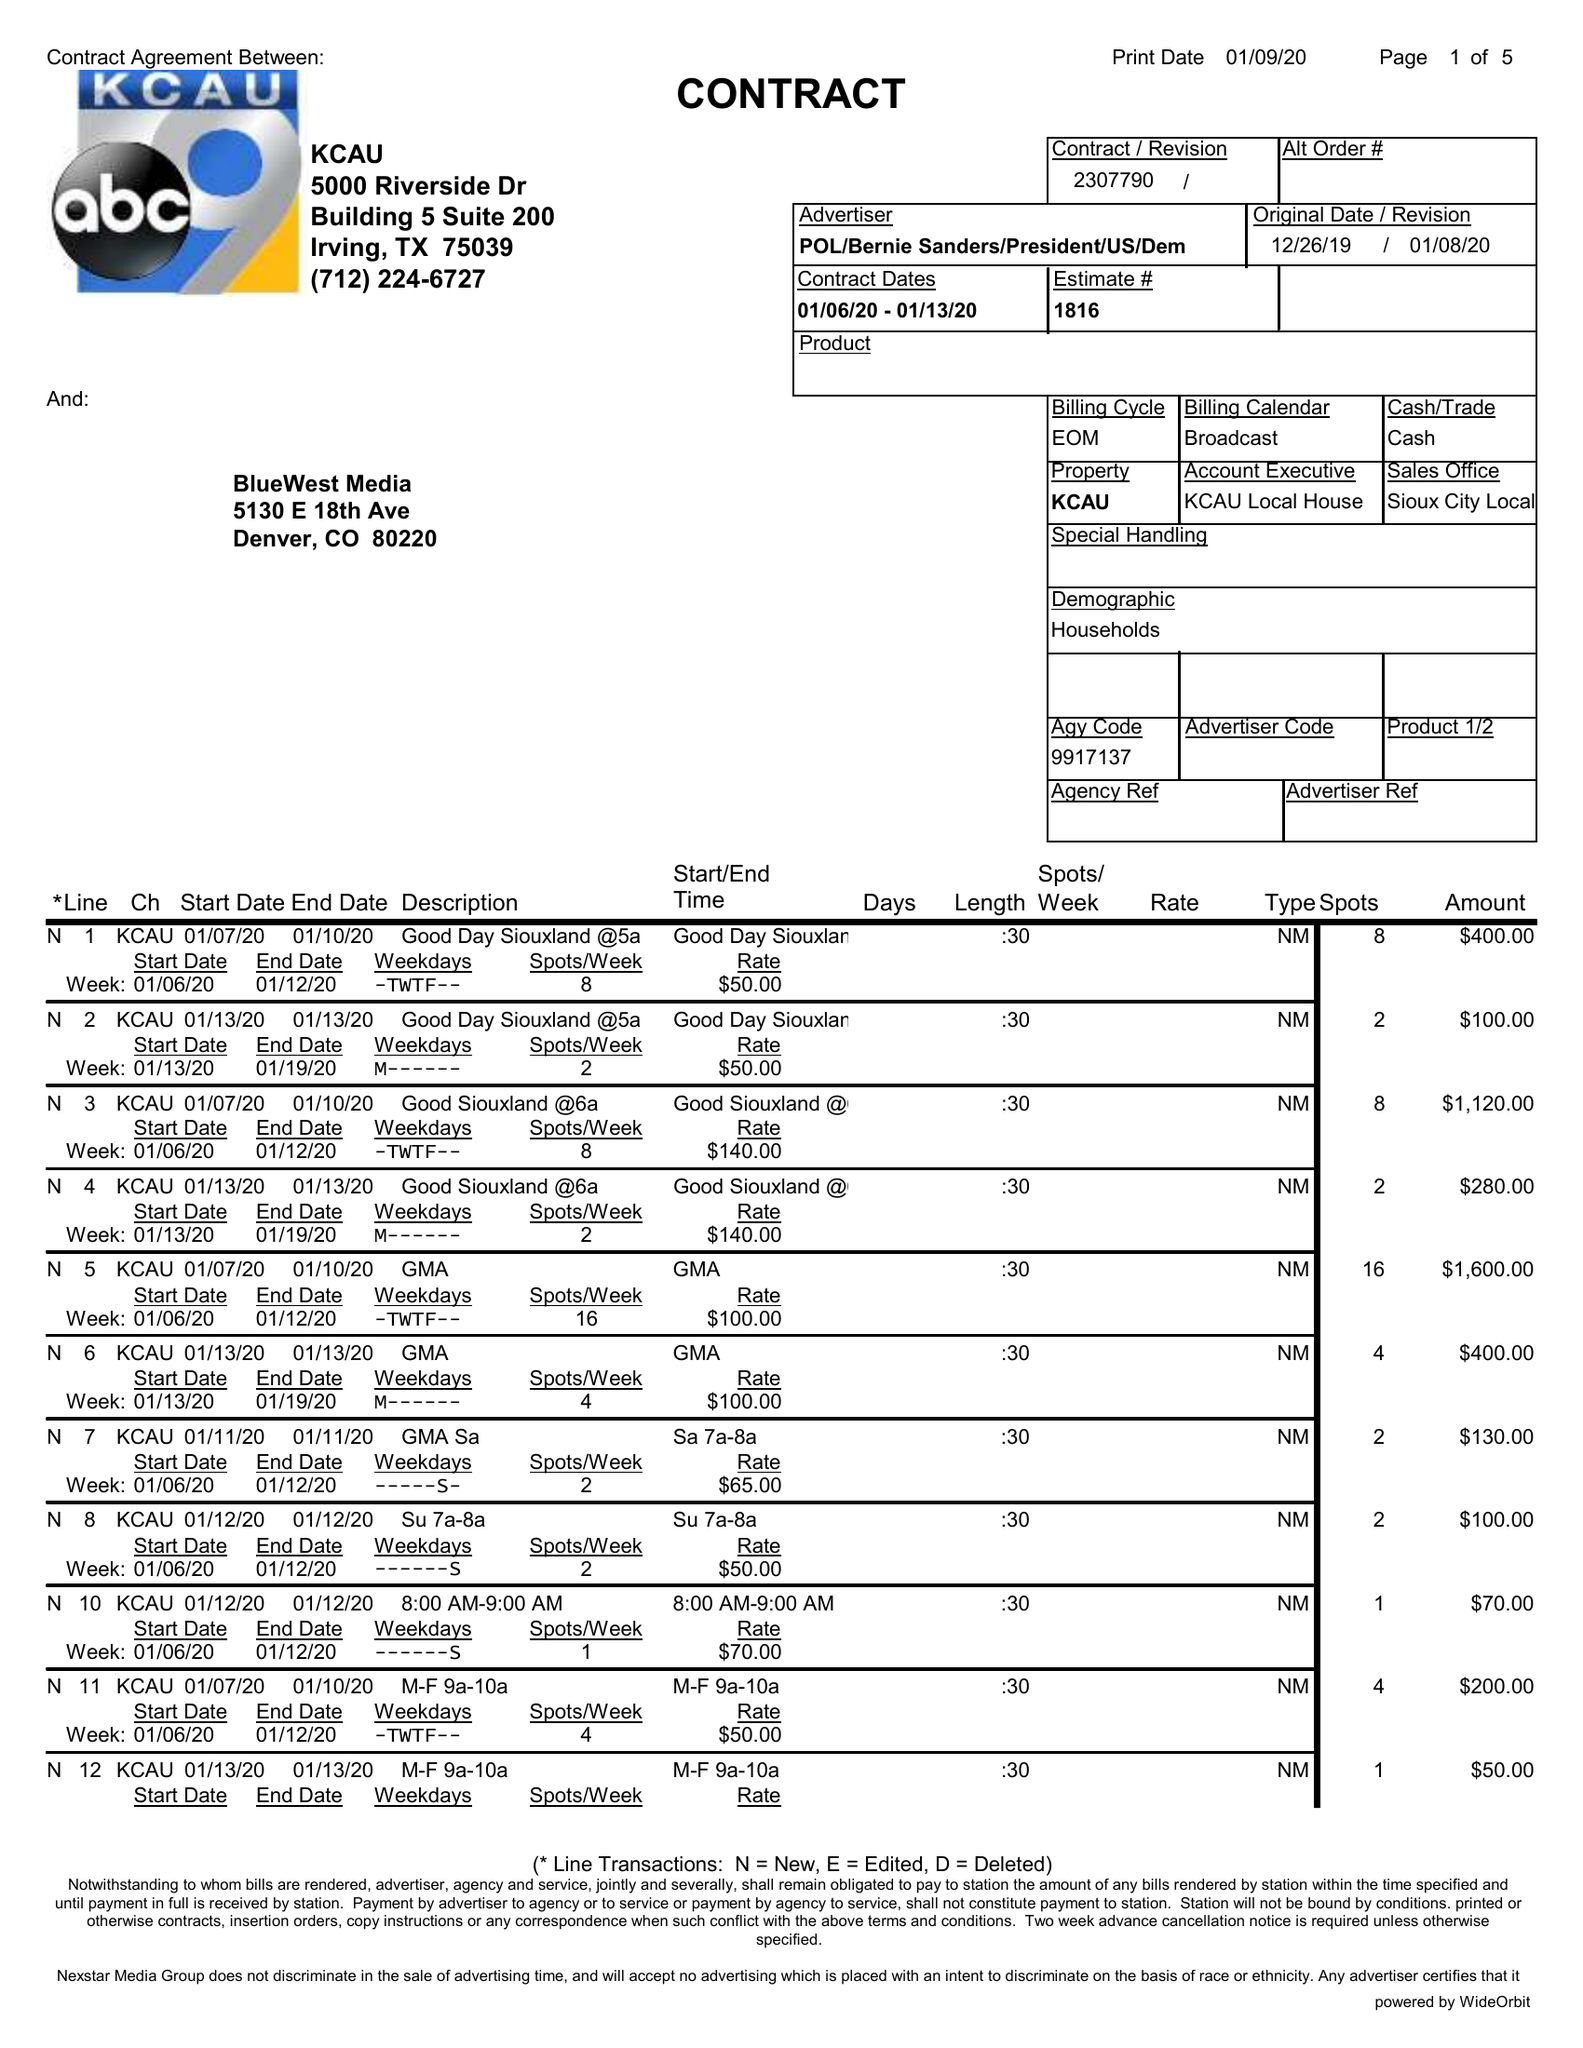What is the value for the contract_num?
Answer the question using a single word or phrase. 2307790 